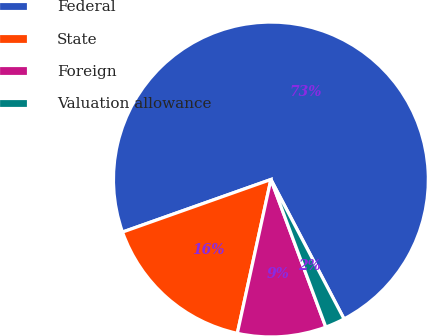Convert chart to OTSL. <chart><loc_0><loc_0><loc_500><loc_500><pie_chart><fcel>Federal<fcel>State<fcel>Foreign<fcel>Valuation allowance<nl><fcel>72.72%<fcel>16.16%<fcel>9.09%<fcel>2.02%<nl></chart> 